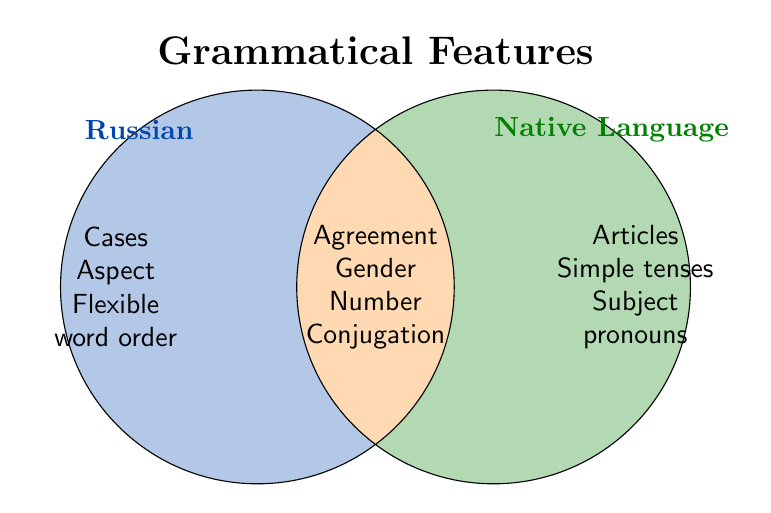What grammatical feature is exclusive to Russian? The Russian-only section of the diagram lists the features: Cases, Aspect, and Flexible word order.
Answer: Cases, Aspect, Flexible word order What grammatical features are shared between Russian and the native language? In the intersection (both) section, the figure lists Agreement, Gender, Number, and Conjugation as shared features.
Answer: Agreement, Gender, Number, Conjugation What is the title of the Venn Diagram? The large text at the top of the Venn Diagram reads "Grammatical Features."
Answer: Grammatical Features Which grammatical feature is exclusive to the native language? The native language only section lists the features: Articles, Simple tenses, and Subject pronouns.
Answer: Articles, Simple tenses, Subject pronouns How many total shared grammatical features are there? Counting the number of features in the "both" section gives us Subject-verb agreement, Gender, Singular and plural forms, and Verb conjugation, totaling 4 features.
Answer: 4 How many grammatical features are exclusive to Russian? The Russian-only section lists Cases, Aspect, and Flexible word order, totaling 3 features.
Answer: 3 Which section of the Venn Diagram has the most features? By counting the features, Russian-only has 3, Native Language only has 3, and both has 4. The "both" section has the most.
Answer: Both What grammatical feature is found in both languages but not mentioned in either singularly? The shared section lists Subject-verb agreement, Gender, Number, Conjugation, all of which are not repeated in the individual categories.
Answer: Subject-verb agreement, Gender, Number, Conjugation 